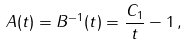<formula> <loc_0><loc_0><loc_500><loc_500>A ( t ) = B ^ { - 1 } ( t ) = \frac { C _ { 1 } } { t } - 1 \, ,</formula> 